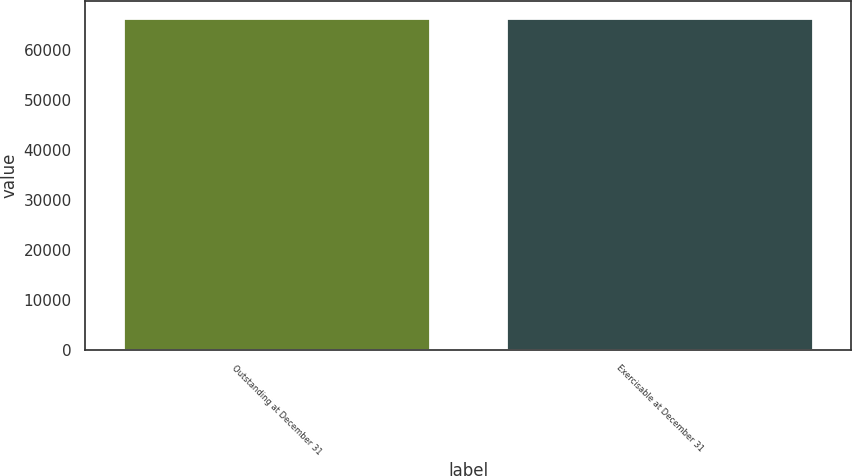<chart> <loc_0><loc_0><loc_500><loc_500><bar_chart><fcel>Outstanding at December 31<fcel>Exercisable at December 31<nl><fcel>66464<fcel>66400<nl></chart> 